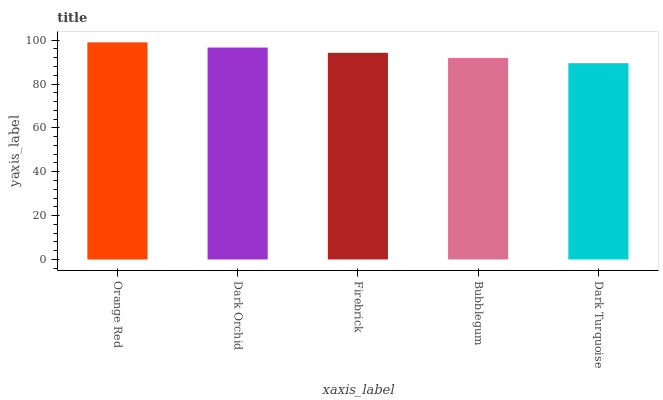Is Dark Turquoise the minimum?
Answer yes or no. Yes. Is Orange Red the maximum?
Answer yes or no. Yes. Is Dark Orchid the minimum?
Answer yes or no. No. Is Dark Orchid the maximum?
Answer yes or no. No. Is Orange Red greater than Dark Orchid?
Answer yes or no. Yes. Is Dark Orchid less than Orange Red?
Answer yes or no. Yes. Is Dark Orchid greater than Orange Red?
Answer yes or no. No. Is Orange Red less than Dark Orchid?
Answer yes or no. No. Is Firebrick the high median?
Answer yes or no. Yes. Is Firebrick the low median?
Answer yes or no. Yes. Is Orange Red the high median?
Answer yes or no. No. Is Orange Red the low median?
Answer yes or no. No. 